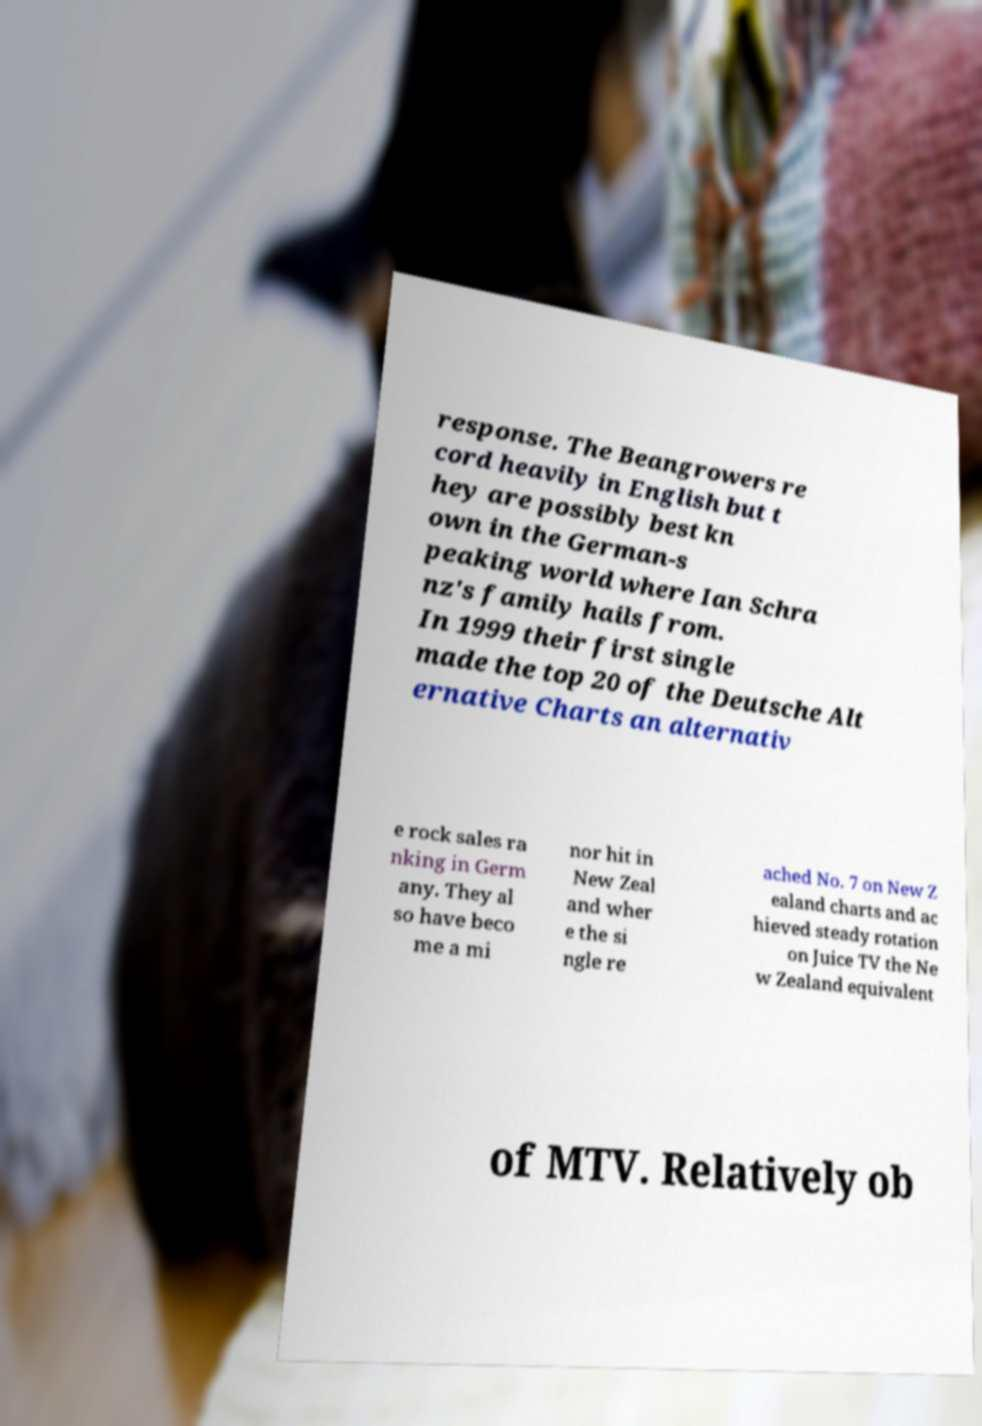Can you accurately transcribe the text from the provided image for me? response. The Beangrowers re cord heavily in English but t hey are possibly best kn own in the German-s peaking world where Ian Schra nz's family hails from. In 1999 their first single made the top 20 of the Deutsche Alt ernative Charts an alternativ e rock sales ra nking in Germ any. They al so have beco me a mi nor hit in New Zeal and wher e the si ngle re ached No. 7 on New Z ealand charts and ac hieved steady rotation on Juice TV the Ne w Zealand equivalent of MTV. Relatively ob 